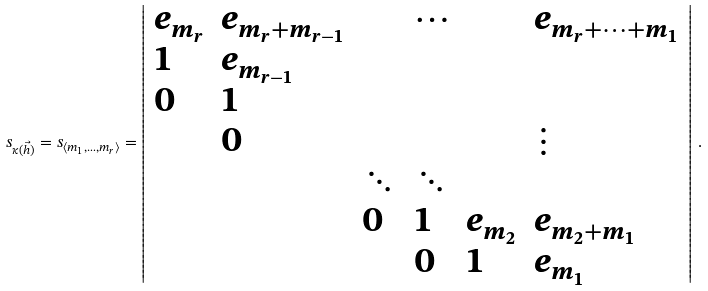<formula> <loc_0><loc_0><loc_500><loc_500>s _ { \kappa ( \vec { h } ) } = s _ { \langle m _ { 1 } , \dots , m _ { r } \rangle } = \left | \begin{array} { l l l l l l } e _ { m _ { r } } & e _ { m _ { r } + m _ { r - 1 } } & & \cdots & & e _ { m _ { r } + \cdots + m _ { 1 } } \\ 1 & e _ { m _ { r - 1 } } \\ 0 & 1 \\ & 0 & & & & \vdots \\ & & \ddots & \ddots \\ & & 0 & 1 & e _ { m _ { 2 } } & e _ { m _ { 2 } + m _ { 1 } } \\ & & & 0 & 1 & e _ { m _ { 1 } } \end{array} \right | \, .</formula> 